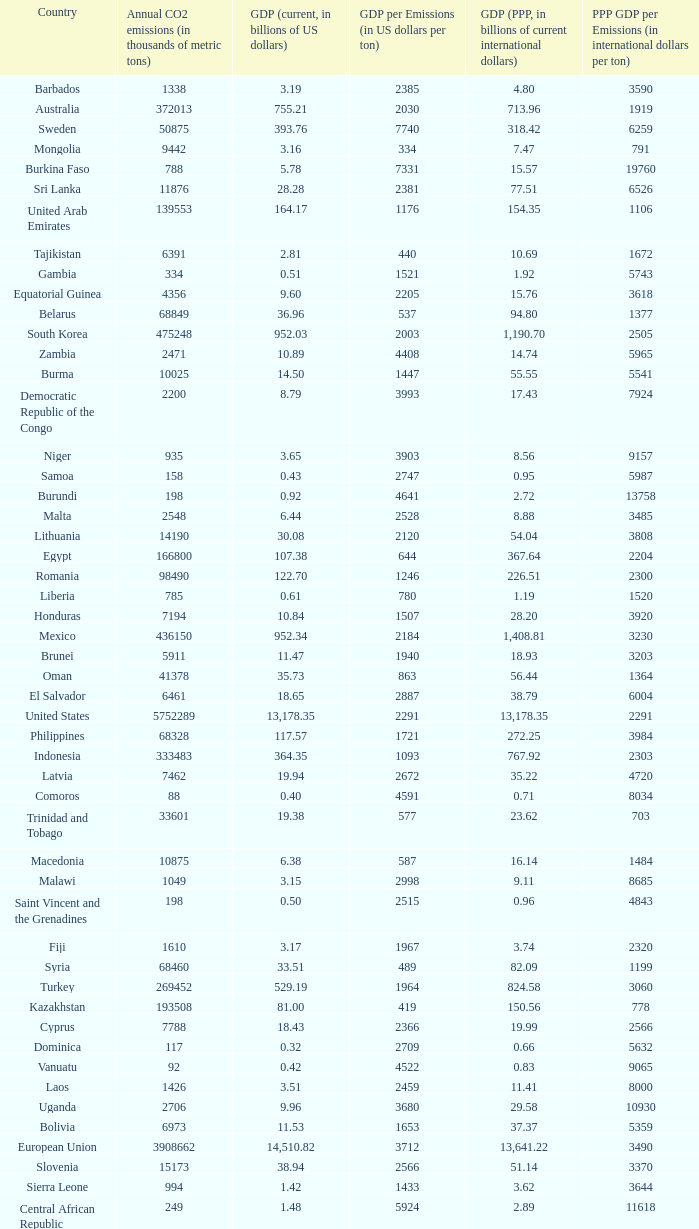When the gdp (ppp, in billions of current international dollars) is 7.93, what is the maximum ppp gdp per emissions (in international dollars per ton)? 9960.0. 